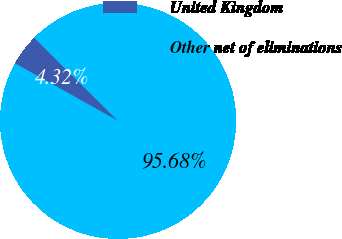<chart> <loc_0><loc_0><loc_500><loc_500><pie_chart><fcel>United Kingdom<fcel>Other net of eliminations<nl><fcel>4.32%<fcel>95.68%<nl></chart> 